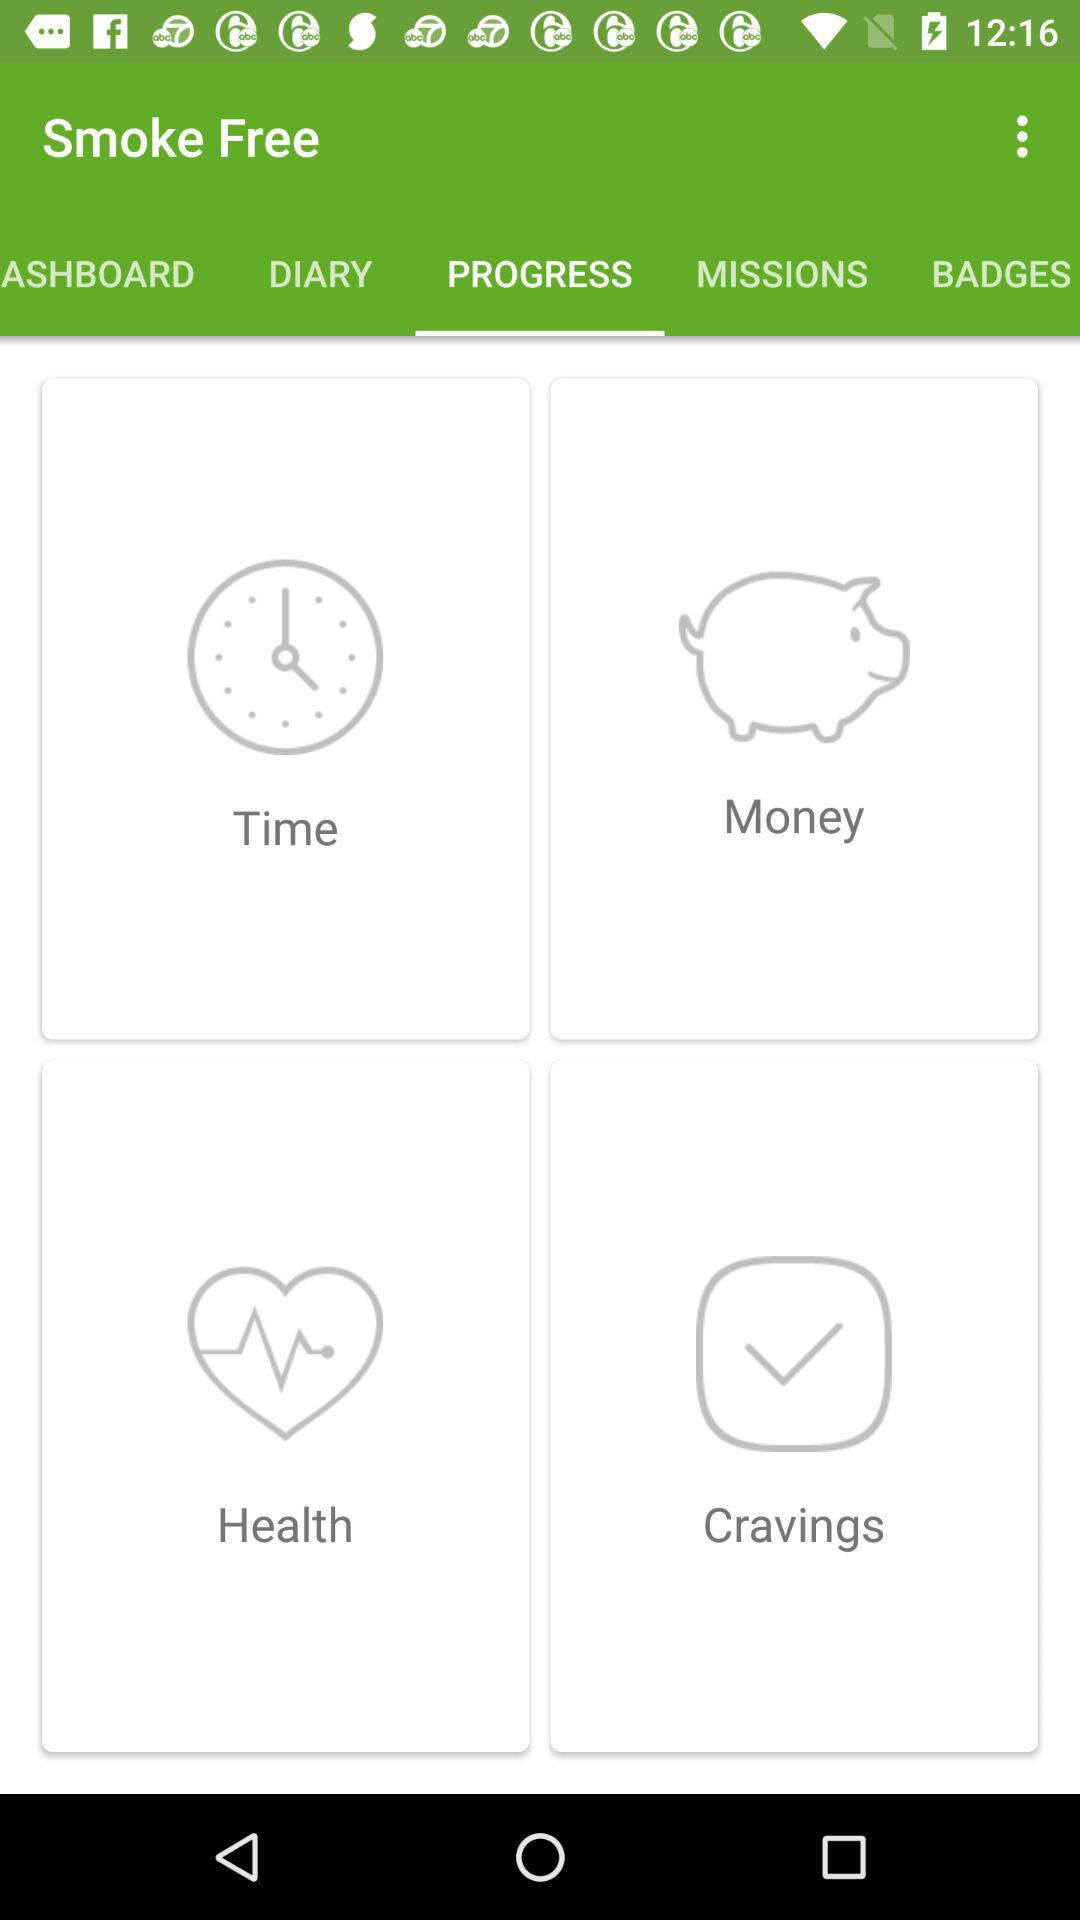How long has the user logged progress with "Smoke Free"?
When the provided information is insufficient, respond with <no answer>. <no answer> 